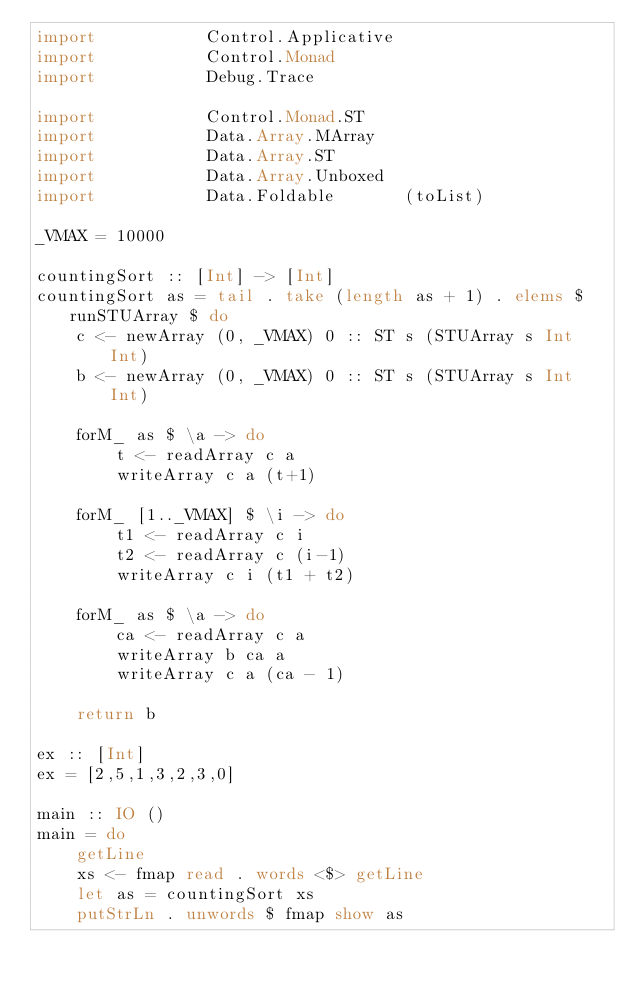<code> <loc_0><loc_0><loc_500><loc_500><_Haskell_>import           Control.Applicative
import           Control.Monad
import           Debug.Trace

import           Control.Monad.ST
import           Data.Array.MArray
import           Data.Array.ST
import           Data.Array.Unboxed
import           Data.Foldable       (toList)

_VMAX = 10000

countingSort :: [Int] -> [Int]
countingSort as = tail . take (length as + 1) . elems $ runSTUArray $ do
    c <- newArray (0, _VMAX) 0 :: ST s (STUArray s Int Int)
    b <- newArray (0, _VMAX) 0 :: ST s (STUArray s Int Int)

    forM_ as $ \a -> do
        t <- readArray c a
        writeArray c a (t+1)

    forM_ [1.._VMAX] $ \i -> do
        t1 <- readArray c i
        t2 <- readArray c (i-1)
        writeArray c i (t1 + t2)

    forM_ as $ \a -> do
        ca <- readArray c a
        writeArray b ca a
        writeArray c a (ca - 1)

    return b

ex :: [Int]
ex = [2,5,1,3,2,3,0]

main :: IO ()
main = do
    getLine
    xs <- fmap read . words <$> getLine
    let as = countingSort xs
    putStrLn . unwords $ fmap show as

</code> 